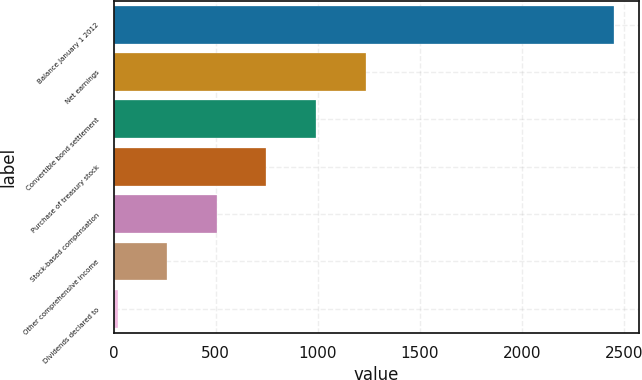<chart> <loc_0><loc_0><loc_500><loc_500><bar_chart><fcel>Balance January 1 2012<fcel>Net earnings<fcel>Convertible bond settlement<fcel>Purchase of treasury stock<fcel>Stock-based compensation<fcel>Other comprehensive income<fcel>Dividends declared to<nl><fcel>2453<fcel>1235.95<fcel>992.54<fcel>749.13<fcel>505.72<fcel>262.31<fcel>18.9<nl></chart> 